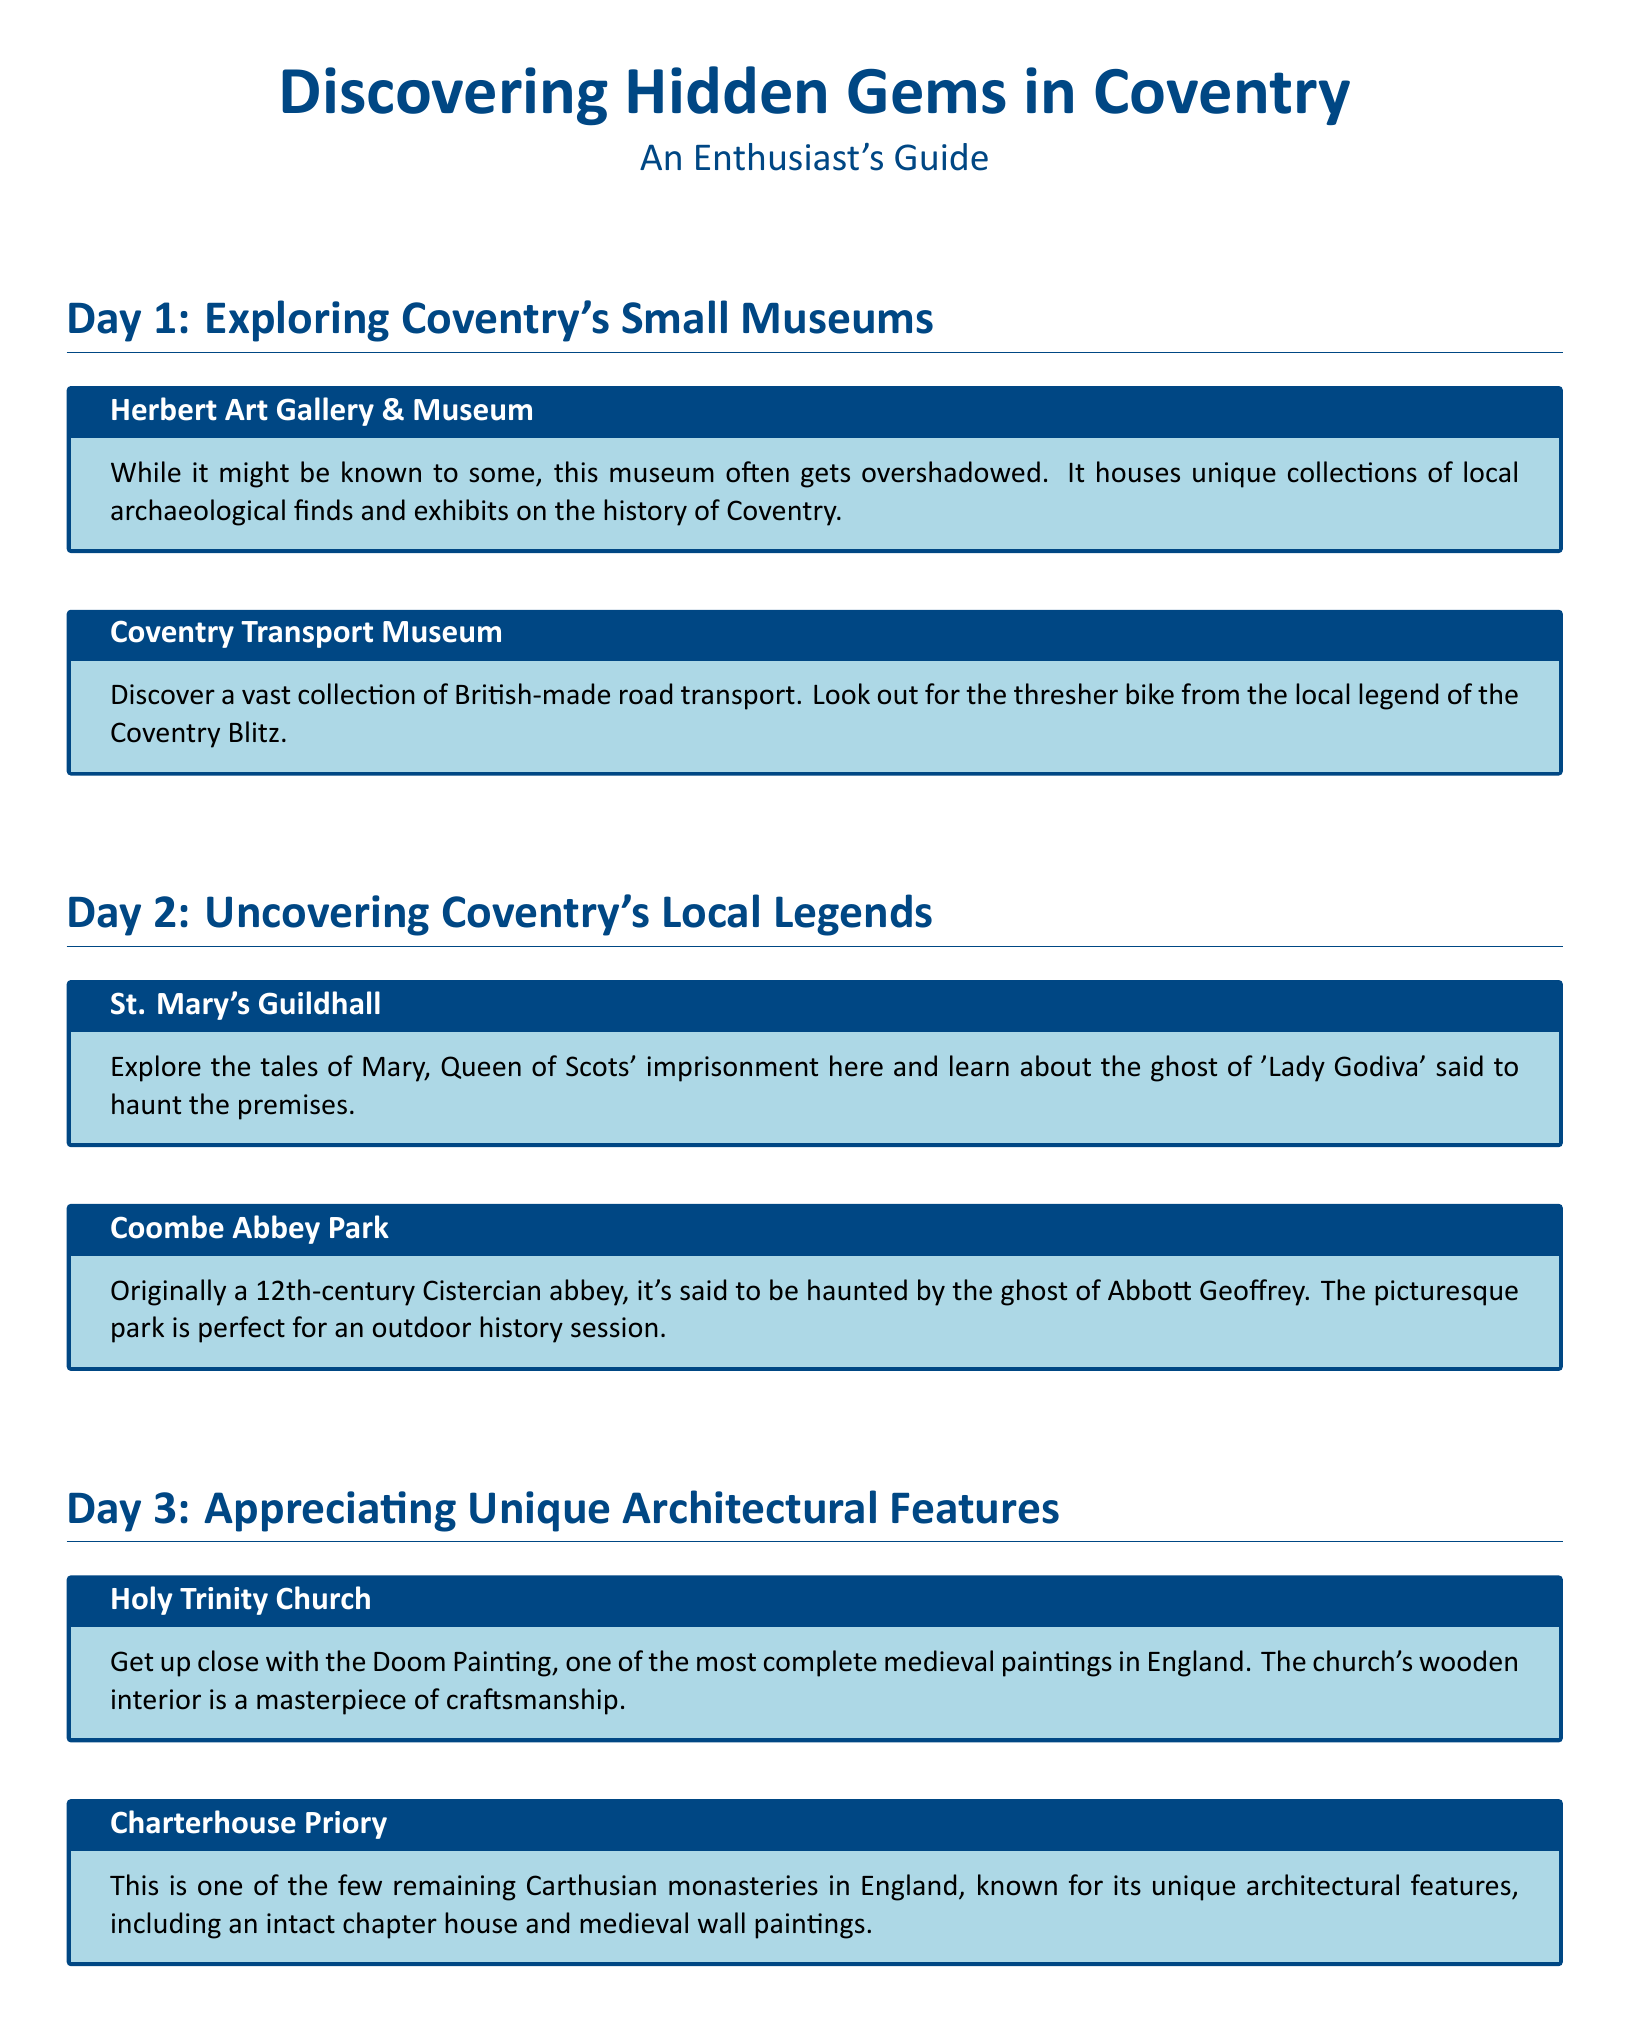what is the title of the itinerary? The title of the itinerary is prominently displayed at the top of the document, indicating its focus on discovering hidden gems in Coventry.
Answer: Discovering Hidden Gems in Coventry how many days are outlined in the itinerary? The itinerary is structured into three distinct sections, each representing a different day of exploration.
Answer: 3 which museum is known for housing collections of local archaeological finds? The Herbert Art Gallery & Museum is specifically mentioned as housing unique collections of local archaeological finds.
Answer: Herbert Art Gallery & Museum what local legend is associated with the Coventry Transport Museum? The document mentions a local legend regarding a thresher bike from the Coventry Blitz in relation to the Coventry Transport Museum.
Answer: Coventry Blitz what architectural feature is highlighted at Holy Trinity Church? The itinerary notes the Doom Painting as one of the most significant architectural features present at Holy Trinity Church.
Answer: Doom Painting who is said to haunt Coombe Abbey Park? The document states that the ghost of Abbott Geoffrey is said to haunt Coombe Abbey Park, which adds to its historical allure.
Answer: Abbott Geoffrey which iconic figure is associated with St. Mary's Guildhall? The document mentions Mary, Queen of Scots, highlighting her historical connection to St. Mary's Guildhall.
Answer: Mary, Queen of Scots what is unique about Charterhouse Priory? Charterhouse Priory is described as one of the few remaining Carthusian monasteries in England, showcasing its uniqueness.
Answer: Carthusian monasteries which day focuses on local legends? The second day of the itinerary specifically emphasizes the theme of uncovering local legends related to Coventry's history.
Answer: Day 2 